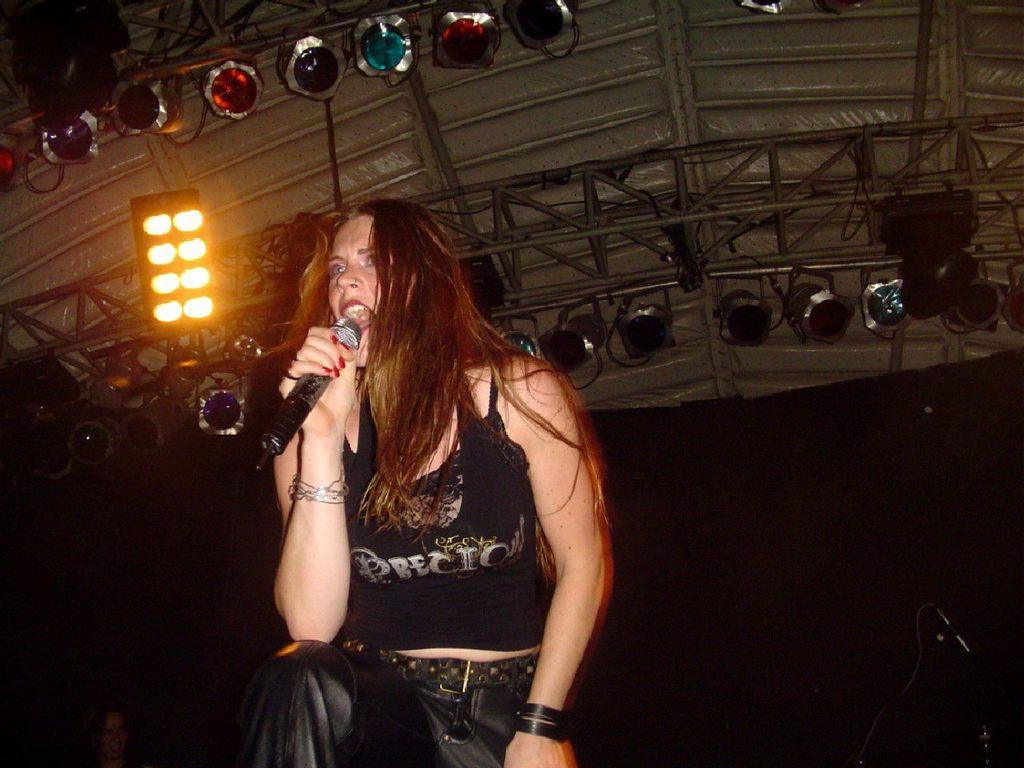What is the person in the image doing? The person is singing. What object is the person holding while singing? The person is holding a microphone. What is the person wearing? The person is wearing a black dress. What can be seen in the background of the image? There are poles and lights in the background of the image. How many ladybugs can be seen on the person's dress in the image? There are no ladybugs visible on the person's dress in the image. What direction is the person turning while singing? The person is not turning in the image; they are standing and singing. 